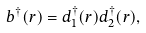Convert formula to latex. <formula><loc_0><loc_0><loc_500><loc_500>b ^ { \dagger } ( { r } ) = d _ { 1 } ^ { \dagger } ( { r } ) d _ { 2 } ^ { \dagger } ( { r } ) ,</formula> 